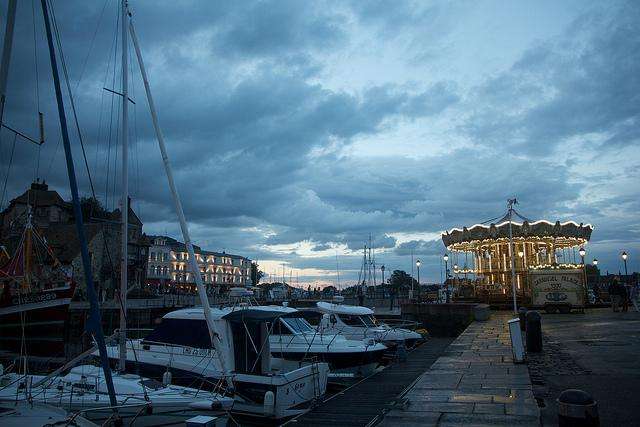What carved imagery animal is likely found on the amusement ride shown here? horse 